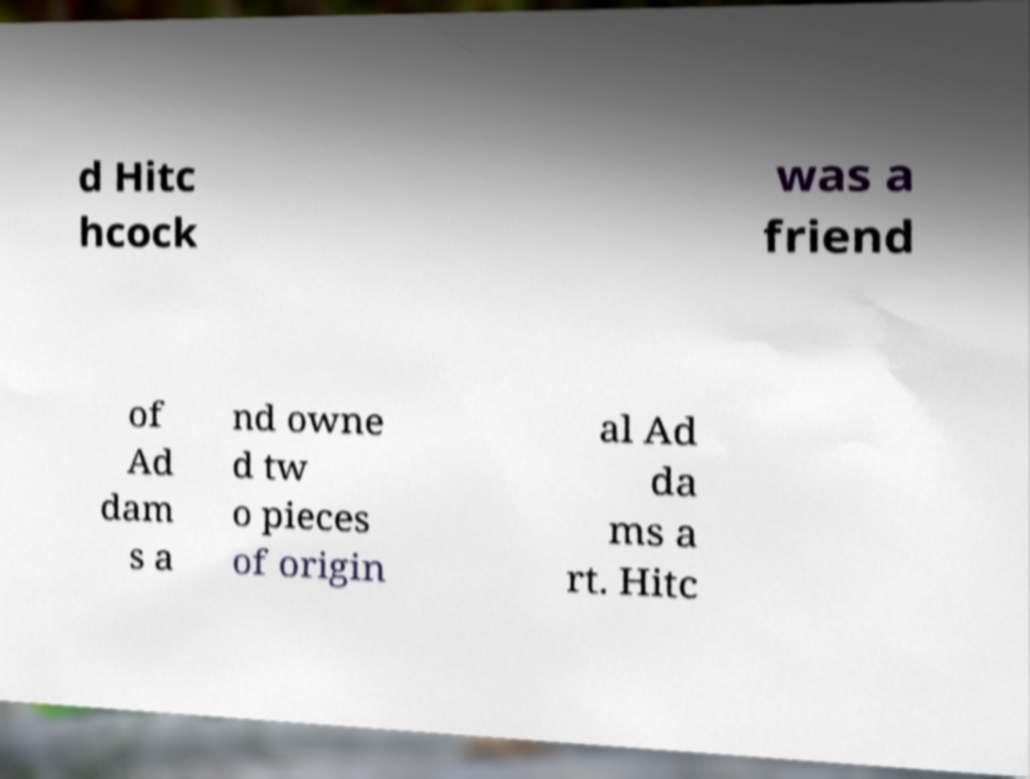Please identify and transcribe the text found in this image. d Hitc hcock was a friend of Ad dam s a nd owne d tw o pieces of origin al Ad da ms a rt. Hitc 